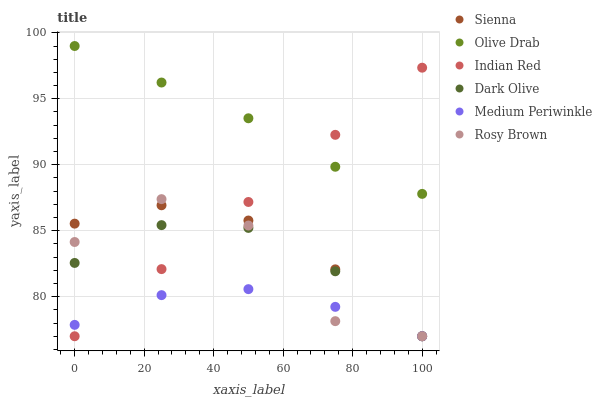Does Medium Periwinkle have the minimum area under the curve?
Answer yes or no. Yes. Does Olive Drab have the maximum area under the curve?
Answer yes or no. Yes. Does Rosy Brown have the minimum area under the curve?
Answer yes or no. No. Does Rosy Brown have the maximum area under the curve?
Answer yes or no. No. Is Indian Red the smoothest?
Answer yes or no. Yes. Is Rosy Brown the roughest?
Answer yes or no. Yes. Is Medium Periwinkle the smoothest?
Answer yes or no. No. Is Medium Periwinkle the roughest?
Answer yes or no. No. Does Dark Olive have the lowest value?
Answer yes or no. Yes. Does Olive Drab have the lowest value?
Answer yes or no. No. Does Olive Drab have the highest value?
Answer yes or no. Yes. Does Rosy Brown have the highest value?
Answer yes or no. No. Is Dark Olive less than Olive Drab?
Answer yes or no. Yes. Is Olive Drab greater than Rosy Brown?
Answer yes or no. Yes. Does Medium Periwinkle intersect Dark Olive?
Answer yes or no. Yes. Is Medium Periwinkle less than Dark Olive?
Answer yes or no. No. Is Medium Periwinkle greater than Dark Olive?
Answer yes or no. No. Does Dark Olive intersect Olive Drab?
Answer yes or no. No. 